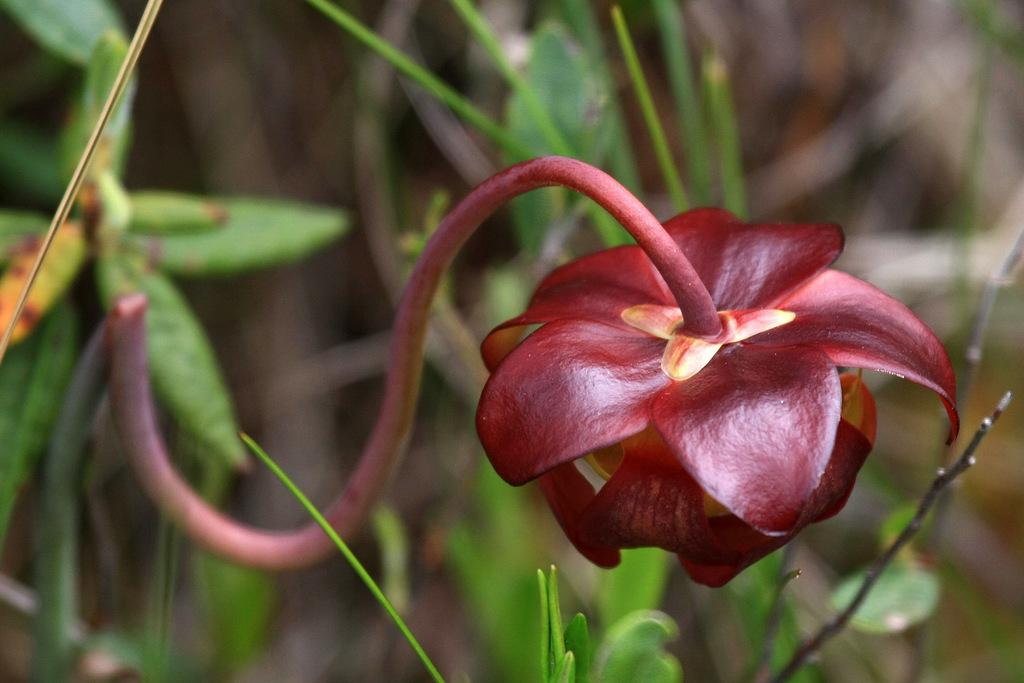What is the color of the flower in the image? The flower in the image is maroon in color. What can be seen in the background of the image? There are plants in green color in the background of the image. What type of achievement is the flower celebrating in the image? The flower is not celebrating any achievement in the image, as it is a static object and not a living being capable of celebrating. 